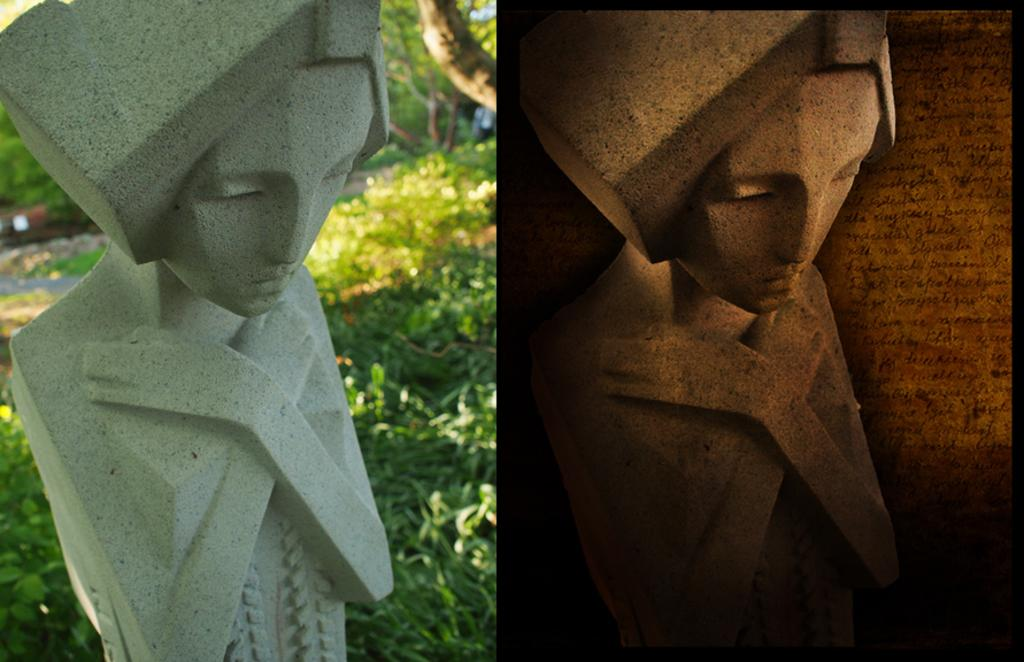How many lady statues are in the image? There are two lady statues in the image. Where are the statues located in relation to each other? One statue is on the right side, and the other is on the left side. What is the color of the statues? Both statues are brown in color. What else can be seen on the left side of the image? There are plants on the left side of the image. What type of company is associated with the spoon in the image? There is no spoon present in the image, so it is not possible to associate it with any company. 